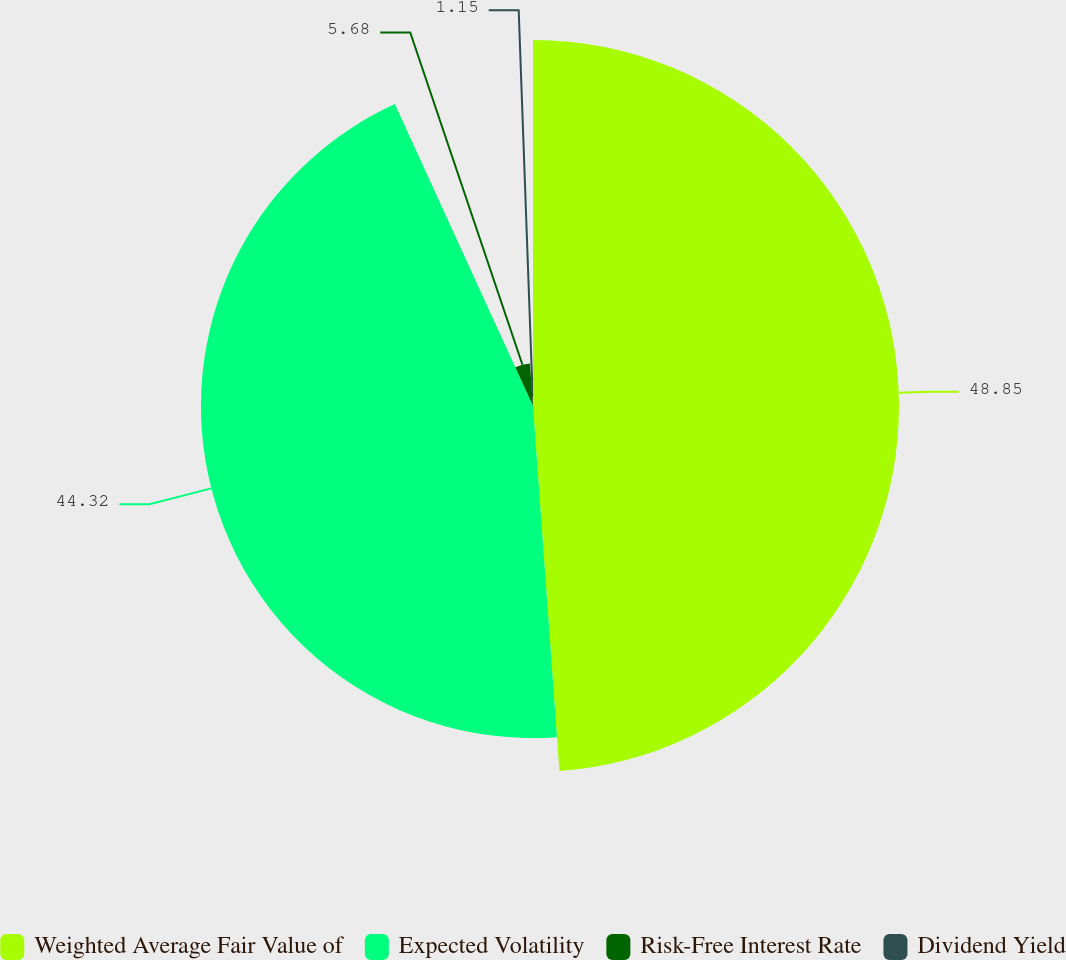Convert chart to OTSL. <chart><loc_0><loc_0><loc_500><loc_500><pie_chart><fcel>Weighted Average Fair Value of<fcel>Expected Volatility<fcel>Risk-Free Interest Rate<fcel>Dividend Yield<nl><fcel>48.85%<fcel>44.32%<fcel>5.68%<fcel>1.15%<nl></chart> 